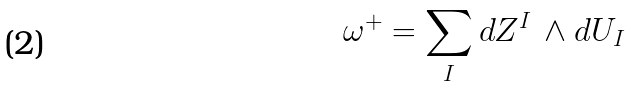Convert formula to latex. <formula><loc_0><loc_0><loc_500><loc_500>\omega ^ { + } = \sum _ { I } d Z ^ { I } \, \wedge d U _ { I }</formula> 